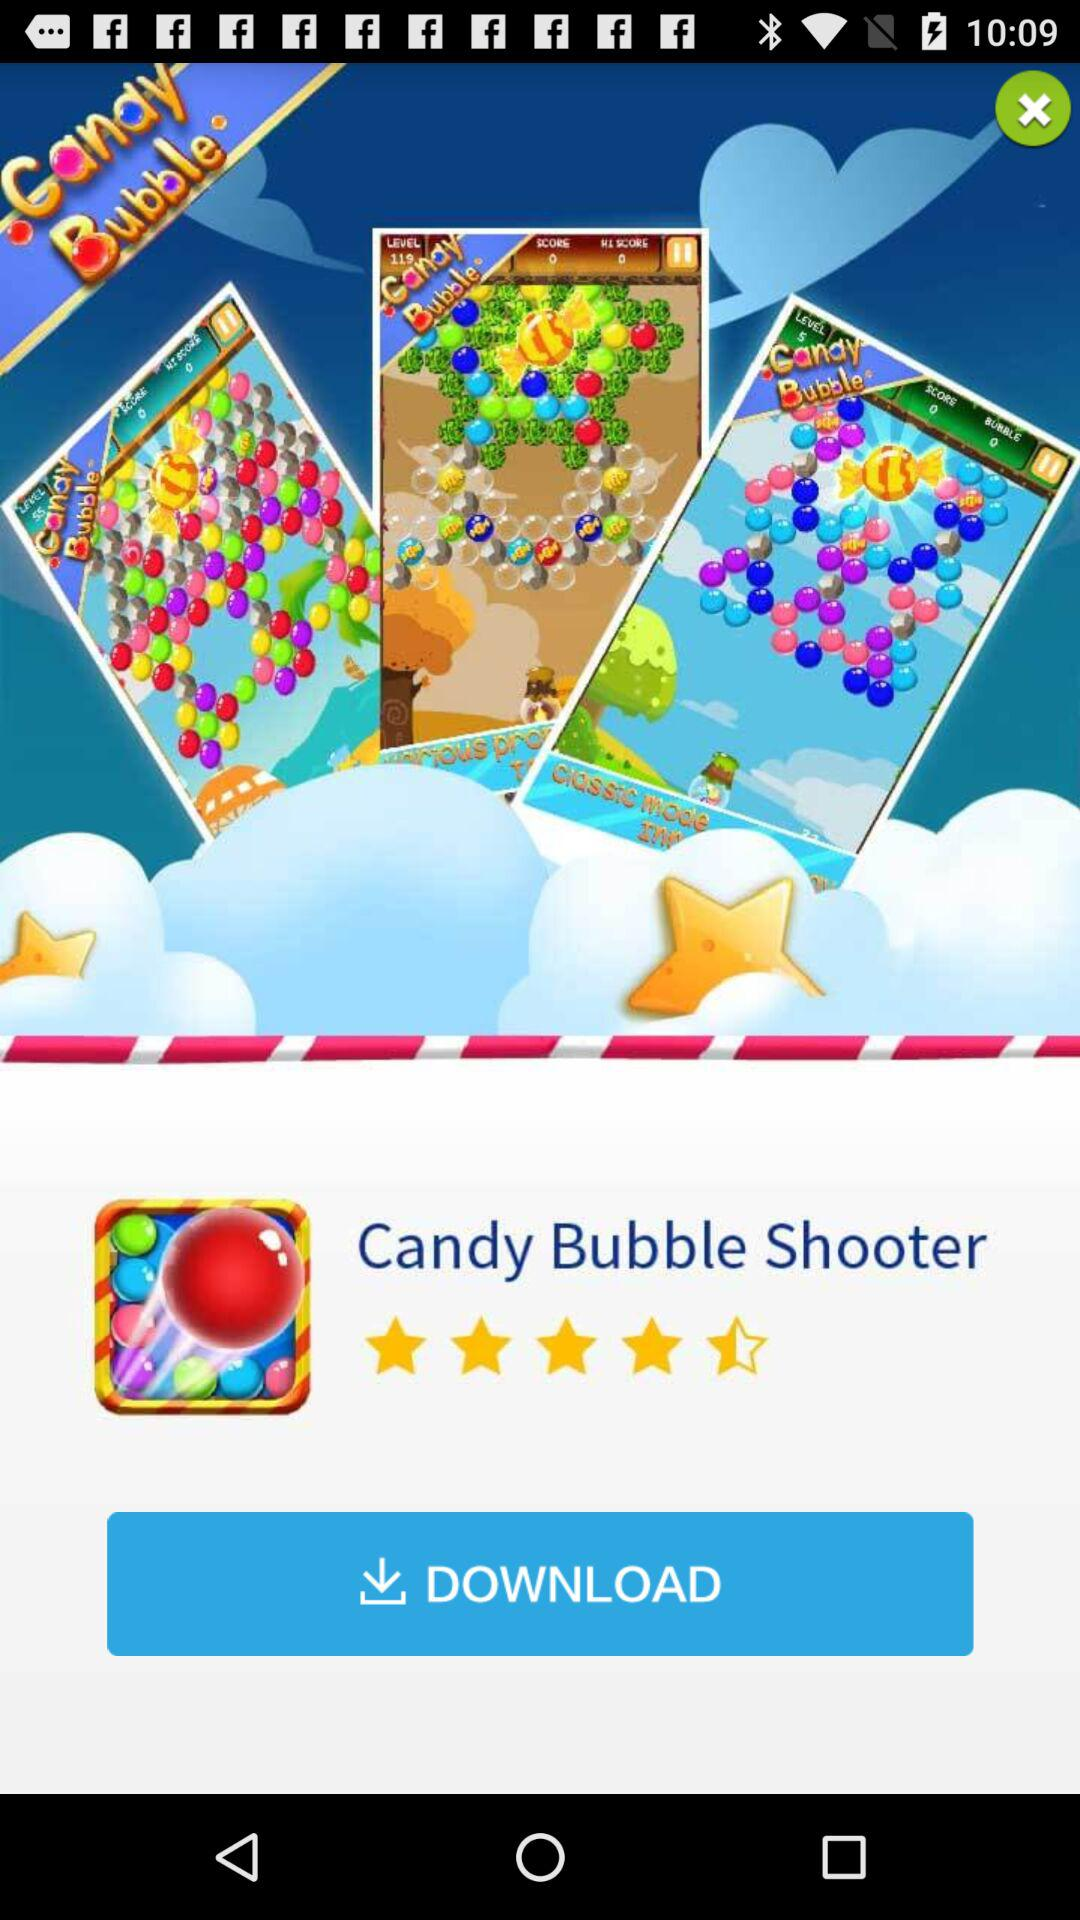What are the given ratings? The given rating is 4.5 stars. 